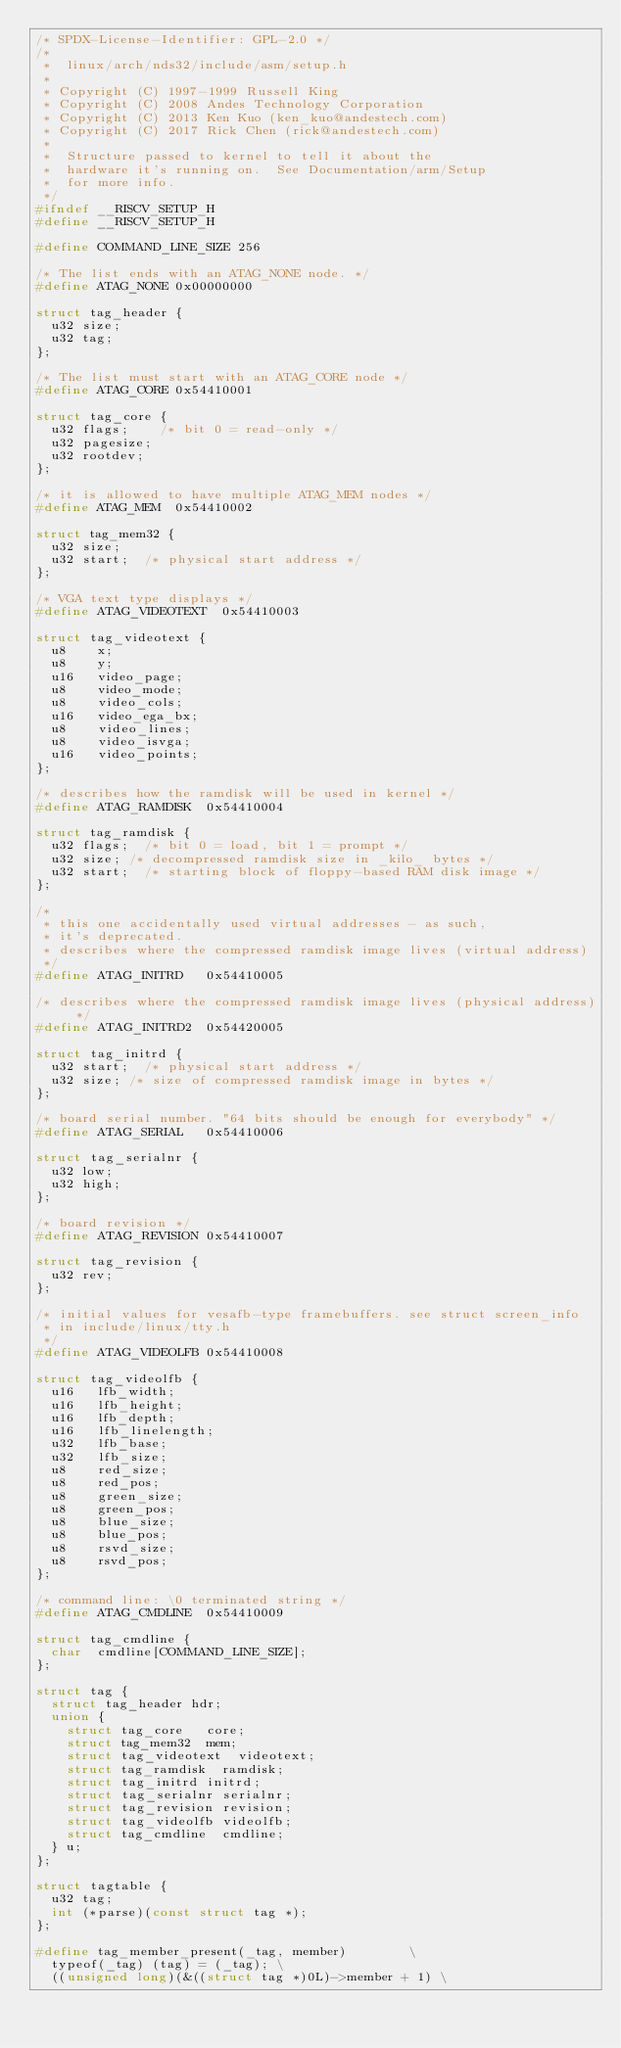<code> <loc_0><loc_0><loc_500><loc_500><_C_>/* SPDX-License-Identifier: GPL-2.0 */
/*
 *  linux/arch/nds32/include/asm/setup.h
 *
 * Copyright (C) 1997-1999 Russell King
 * Copyright (C) 2008 Andes Technology Corporation
 * Copyright (C) 2013 Ken Kuo (ken_kuo@andestech.com)
 * Copyright (C) 2017 Rick Chen (rick@andestech.com)
 *
 *  Structure passed to kernel to tell it about the
 *  hardware it's running on.  See Documentation/arm/Setup
 *  for more info.
 */
#ifndef __RISCV_SETUP_H
#define __RISCV_SETUP_H

#define COMMAND_LINE_SIZE 256

/* The list ends with an ATAG_NONE node. */
#define ATAG_NONE	0x00000000

struct tag_header {
	u32 size;
	u32 tag;
};

/* The list must start with an ATAG_CORE node */
#define ATAG_CORE	0x54410001

struct tag_core {
	u32 flags;		/* bit 0 = read-only */
	u32 pagesize;
	u32 rootdev;
};

/* it is allowed to have multiple ATAG_MEM nodes */
#define ATAG_MEM	0x54410002

struct tag_mem32 {
	u32	size;
	u32	start;	/* physical start address */
};

/* VGA text type displays */
#define ATAG_VIDEOTEXT	0x54410003

struct tag_videotext {
	u8		x;
	u8		y;
	u16		video_page;
	u8		video_mode;
	u8		video_cols;
	u16		video_ega_bx;
	u8		video_lines;
	u8		video_isvga;
	u16		video_points;
};

/* describes how the ramdisk will be used in kernel */
#define ATAG_RAMDISK	0x54410004

struct tag_ramdisk {
	u32 flags;	/* bit 0 = load, bit 1 = prompt */
	u32 size;	/* decompressed ramdisk size in _kilo_ bytes */
	u32 start;	/* starting block of floppy-based RAM disk image */
};

/*
 * this one accidentally used virtual addresses - as such,
 * it's deprecated.
 * describes where the compressed ramdisk image lives (virtual address)
 */
#define ATAG_INITRD		0x54410005

/* describes where the compressed ramdisk image lives (physical address) */
#define ATAG_INITRD2	0x54420005

struct tag_initrd {
	u32 start;	/* physical start address */
	u32 size;	/* size of compressed ramdisk image in bytes */
};

/* board serial number. "64 bits should be enough for everybody" */
#define ATAG_SERIAL		0x54410006

struct tag_serialnr {
	u32 low;
	u32 high;
};

/* board revision */
#define ATAG_REVISION	0x54410007

struct tag_revision {
	u32 rev;
};

/* initial values for vesafb-type framebuffers. see struct screen_info
 * in include/linux/tty.h
 */
#define ATAG_VIDEOLFB	0x54410008

struct tag_videolfb {
	u16		lfb_width;
	u16		lfb_height;
	u16		lfb_depth;
	u16		lfb_linelength;
	u32		lfb_base;
	u32		lfb_size;
	u8		red_size;
	u8		red_pos;
	u8		green_size;
	u8		green_pos;
	u8		blue_size;
	u8		blue_pos;
	u8		rsvd_size;
	u8		rsvd_pos;
};

/* command line: \0 terminated string */
#define ATAG_CMDLINE	0x54410009

struct tag_cmdline {
	char	cmdline[COMMAND_LINE_SIZE];
};

struct tag {
	struct tag_header hdr;
	union {
		struct tag_core		core;
		struct tag_mem32	mem;
		struct tag_videotext	videotext;
		struct tag_ramdisk	ramdisk;
		struct tag_initrd	initrd;
		struct tag_serialnr	serialnr;
		struct tag_revision	revision;
		struct tag_videolfb	videolfb;
		struct tag_cmdline	cmdline;
	} u;
};

struct tagtable {
	u32 tag;
	int (*parse)(const struct tag *);
};

#define tag_member_present(_tag, member)				\
	typeof(_tag) (tag) = (_tag); \
	((unsigned long)(&((struct tag *)0L)->member + 1)	\</code> 